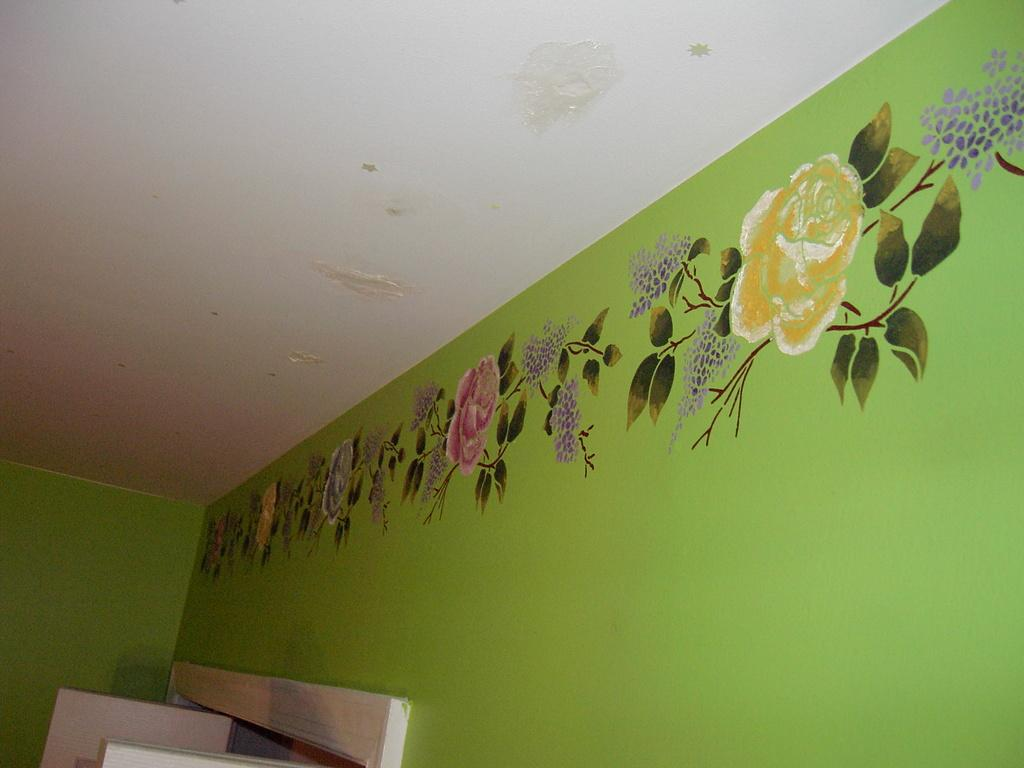What is hanging on the wall in the image? There is a painting on the wall in the image. What color is the wall that the painting is on? The wall is green in color. What part of the building can be seen in the image? The roof is visible in the image. Is there any entrance or exit in the image? Yes, there is a door in the image. What is the size of the circle in the image? There is no circle present in the image. 